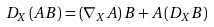<formula> <loc_0><loc_0><loc_500><loc_500>D _ { X } \left ( A B \right ) = \left ( \nabla _ { X } A \right ) B + A \left ( D _ { X } B \right )</formula> 